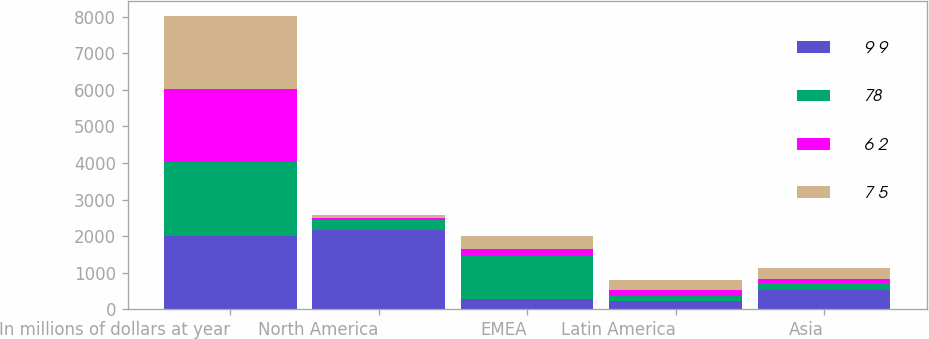Convert chart. <chart><loc_0><loc_0><loc_500><loc_500><stacked_bar_chart><ecel><fcel>In millions of dollars at year<fcel>North America<fcel>EMEA<fcel>Latin America<fcel>Asia<nl><fcel>9 9<fcel>2008<fcel>2160<fcel>290<fcel>238<fcel>541<nl><fcel>78<fcel>2007<fcel>290<fcel>1173<fcel>127<fcel>168<nl><fcel>6 2<fcel>2006<fcel>59<fcel>186<fcel>173<fcel>117<nl><fcel>7 5<fcel>2005<fcel>81<fcel>354<fcel>268<fcel>301<nl></chart> 